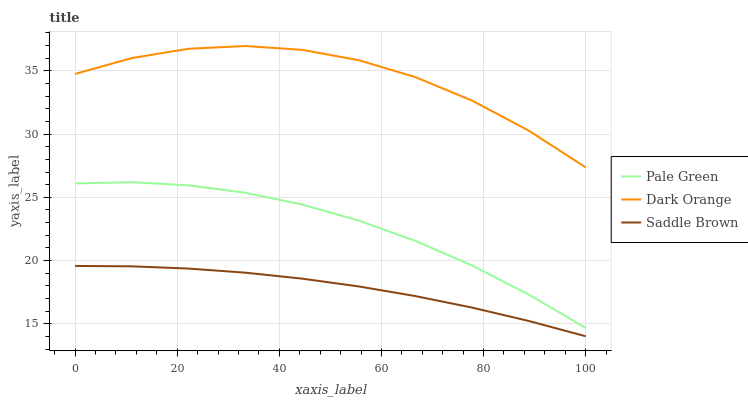Does Saddle Brown have the minimum area under the curve?
Answer yes or no. Yes. Does Dark Orange have the maximum area under the curve?
Answer yes or no. Yes. Does Pale Green have the minimum area under the curve?
Answer yes or no. No. Does Pale Green have the maximum area under the curve?
Answer yes or no. No. Is Saddle Brown the smoothest?
Answer yes or no. Yes. Is Dark Orange the roughest?
Answer yes or no. Yes. Is Pale Green the smoothest?
Answer yes or no. No. Is Pale Green the roughest?
Answer yes or no. No. Does Saddle Brown have the lowest value?
Answer yes or no. Yes. Does Pale Green have the lowest value?
Answer yes or no. No. Does Dark Orange have the highest value?
Answer yes or no. Yes. Does Pale Green have the highest value?
Answer yes or no. No. Is Saddle Brown less than Pale Green?
Answer yes or no. Yes. Is Dark Orange greater than Saddle Brown?
Answer yes or no. Yes. Does Saddle Brown intersect Pale Green?
Answer yes or no. No. 